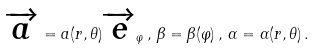<formula> <loc_0><loc_0><loc_500><loc_500>\overrightarrow { a } = a ( r , \theta ) \overrightarrow { e } _ { \varphi } \, , \, \beta = \beta ( \varphi ) \, , \, \alpha = \alpha ( r , \theta ) \, .</formula> 